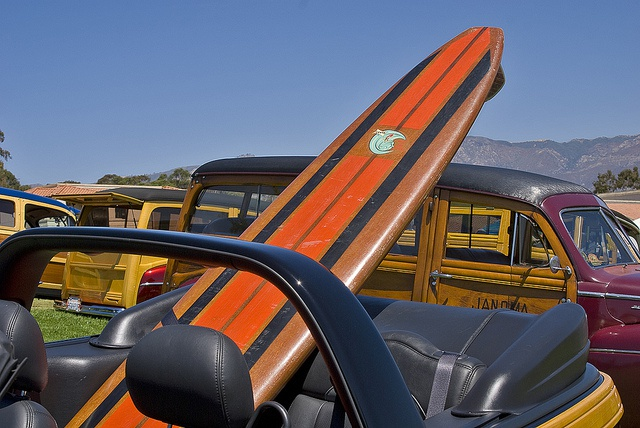Describe the objects in this image and their specific colors. I can see car in gray, black, and darkblue tones, car in gray, black, maroon, and olive tones, surfboard in gray, red, brown, salmon, and black tones, car in gray, black, olive, and maroon tones, and car in gray, black, and tan tones in this image. 